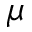Convert formula to latex. <formula><loc_0><loc_0><loc_500><loc_500>\mu</formula> 